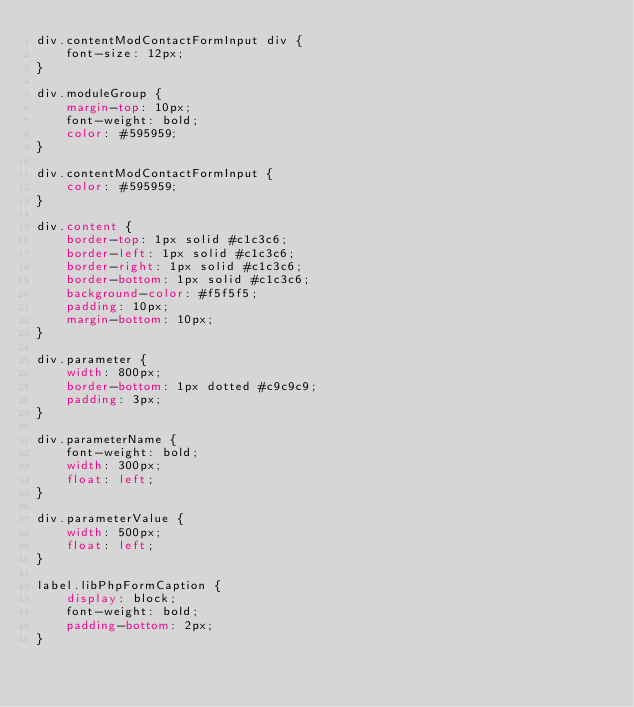<code> <loc_0><loc_0><loc_500><loc_500><_CSS_>div.contentModContactFormInput div {
	font-size: 12px;
}

div.moduleGroup {
	margin-top: 10px;
	font-weight: bold;
	color: #595959;
}

div.contentModContactFormInput {
	color: #595959;
}

div.content {
	border-top: 1px solid #c1c3c6;
	border-left: 1px solid #c1c3c6;
	border-right: 1px solid #c1c3c6;
	border-bottom: 1px solid #c1c3c6;
	background-color: #f5f5f5;
	padding: 10px;
	margin-bottom: 10px;
}

div.parameter {
	width: 800px;
	border-bottom: 1px dotted #c9c9c9;
	padding: 3px;
}

div.parameterName {
	font-weight: bold;
	width: 300px;
	float: left;
}

div.parameterValue {
	width: 500px;
	float: left;
}

label.libPhpFormCaption {
	display: block;
	font-weight: bold;
	padding-bottom: 2px;
}</code> 